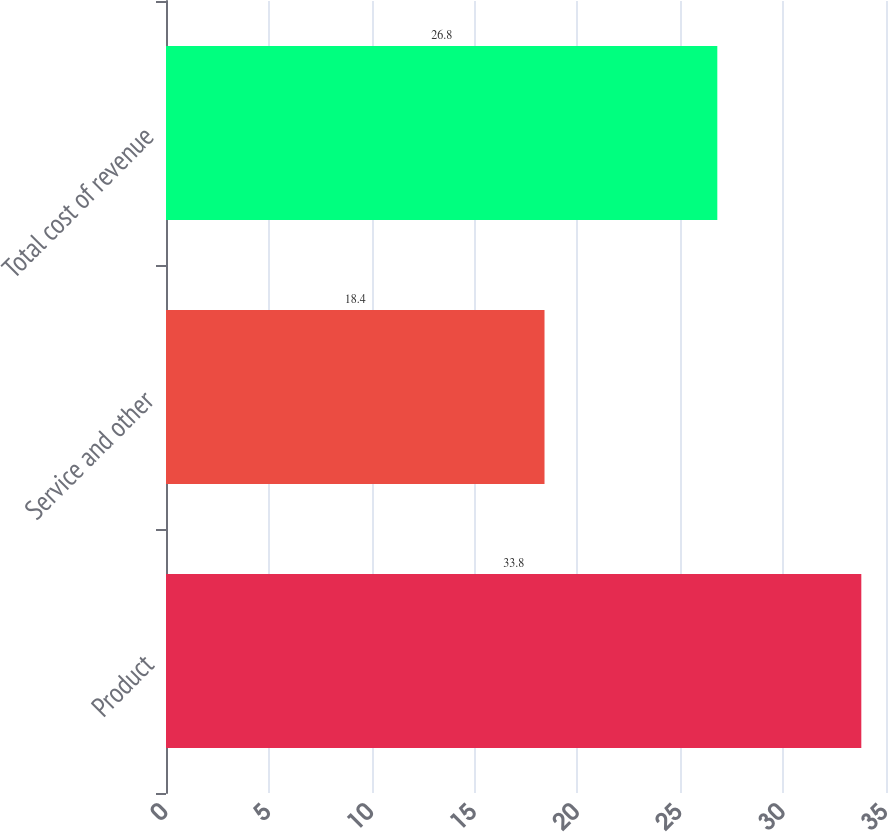Convert chart to OTSL. <chart><loc_0><loc_0><loc_500><loc_500><bar_chart><fcel>Product<fcel>Service and other<fcel>Total cost of revenue<nl><fcel>33.8<fcel>18.4<fcel>26.8<nl></chart> 